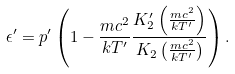Convert formula to latex. <formula><loc_0><loc_0><loc_500><loc_500>\epsilon ^ { \prime } = p ^ { \prime } \left ( 1 - \frac { m c ^ { 2 } } { k T ^ { \prime } } \frac { K ^ { \prime } _ { 2 } \left ( \frac { m c ^ { 2 } } { k T ^ { \prime } } \right ) } { K _ { 2 } \left ( \frac { m c ^ { 2 } } { k T ^ { \prime } } \right ) } \right ) .</formula> 